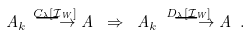<formula> <loc_0><loc_0><loc_500><loc_500>A _ { k } \overset { C _ { \lambda } [ \mathcal { I } _ { W } ] } { \longrightarrow } A \ \Rightarrow \ A _ { k } \overset { D _ { \lambda } [ \mathcal { I } _ { W } ] } { \ \longrightarrow } A \ .</formula> 